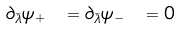Convert formula to latex. <formula><loc_0><loc_0><loc_500><loc_500>\partial _ { \bar { \lambda } } \psi _ { + } \ = \partial _ { \bar { \lambda } } \psi _ { - } \ = 0</formula> 